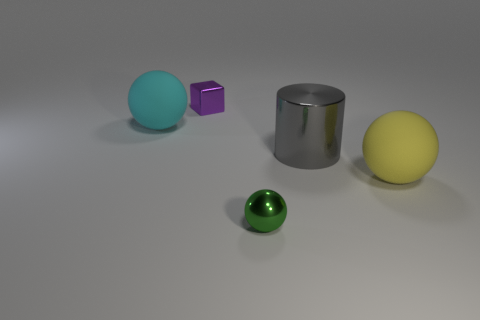Subtract all yellow balls. How many balls are left? 2 Add 2 tiny purple matte spheres. How many objects exist? 7 Subtract 0 blue cylinders. How many objects are left? 5 Subtract all cubes. How many objects are left? 4 Subtract all yellow spheres. Subtract all green cylinders. How many spheres are left? 2 Subtract all large gray metallic cylinders. Subtract all small purple things. How many objects are left? 3 Add 5 gray shiny objects. How many gray shiny objects are left? 6 Add 5 small gray matte cylinders. How many small gray matte cylinders exist? 5 